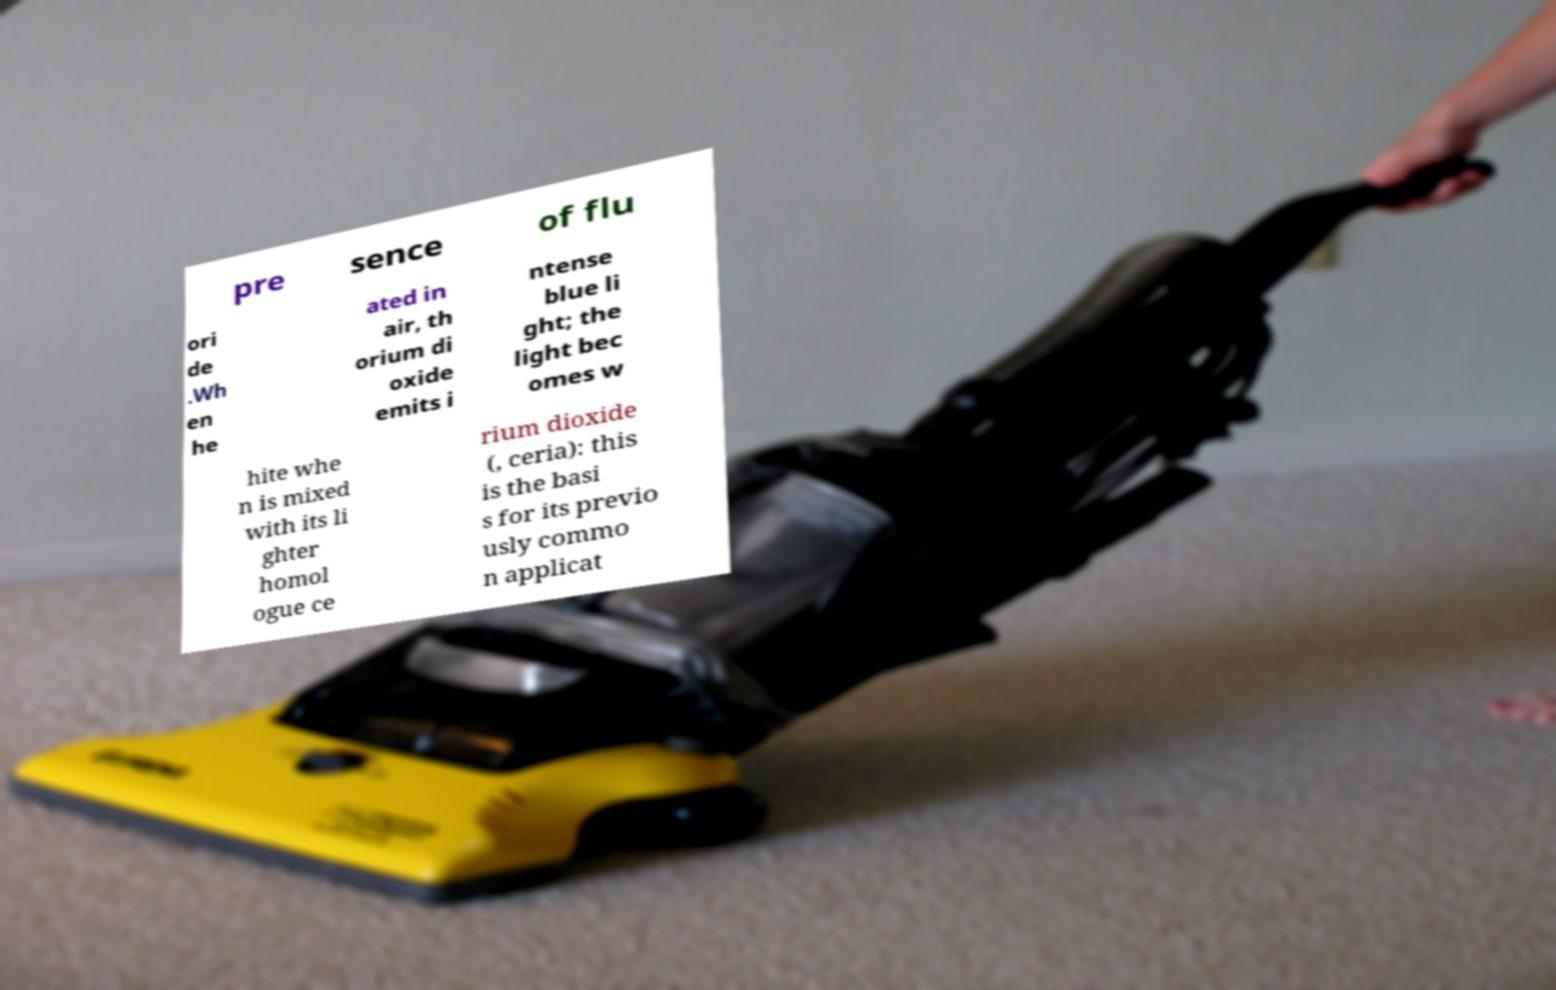Please read and relay the text visible in this image. What does it say? pre sence of flu ori de .Wh en he ated in air, th orium di oxide emits i ntense blue li ght; the light bec omes w hite whe n is mixed with its li ghter homol ogue ce rium dioxide (, ceria): this is the basi s for its previo usly commo n applicat 